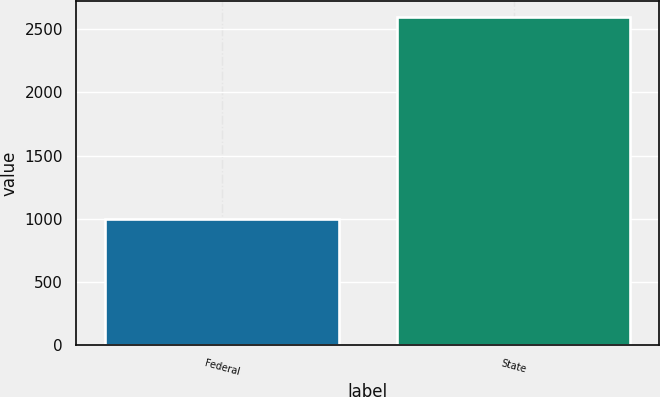<chart> <loc_0><loc_0><loc_500><loc_500><bar_chart><fcel>Federal<fcel>State<nl><fcel>997<fcel>2594<nl></chart> 